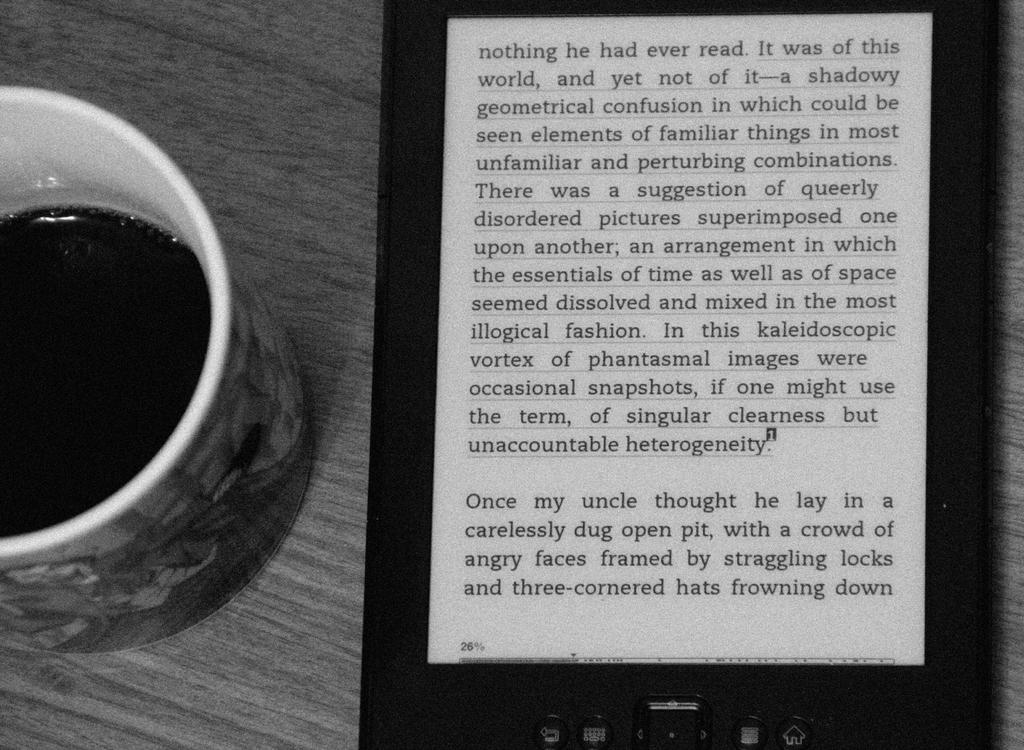What relative of the narrator does the last paragraph talk about?
Your response must be concise. Uncle. What is the last underlined word?
Make the answer very short. Heterogeneity. 